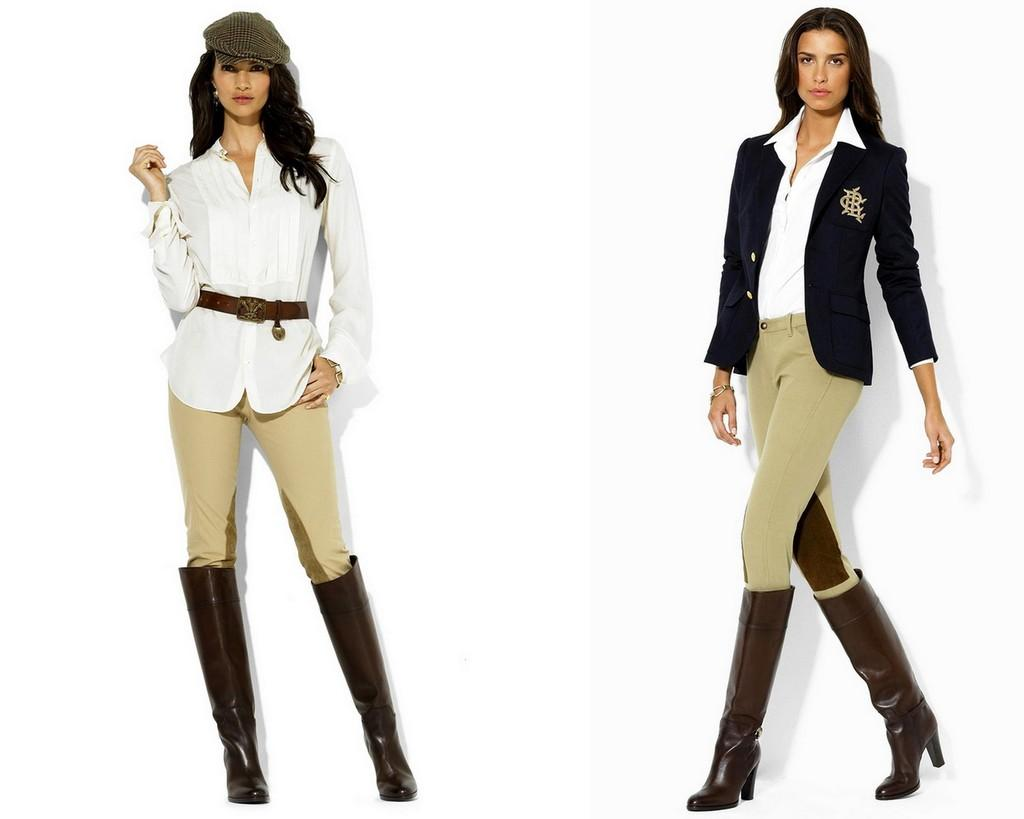How is the image composed? The image is a collage of two pictures. What can be seen in the first picture? In the first picture, there is a woman wearing a white shirt and a cap. What is the woman in the first picture doing? The woman in the first picture is standing. What can be seen in the second picture? In the second picture, there is a woman. What is the woman in the second picture doing? The woman in the second picture is in a walking motion. What is the weight of the bit in the image? There is no bit present in the image, so it is not possible to determine its weight. 